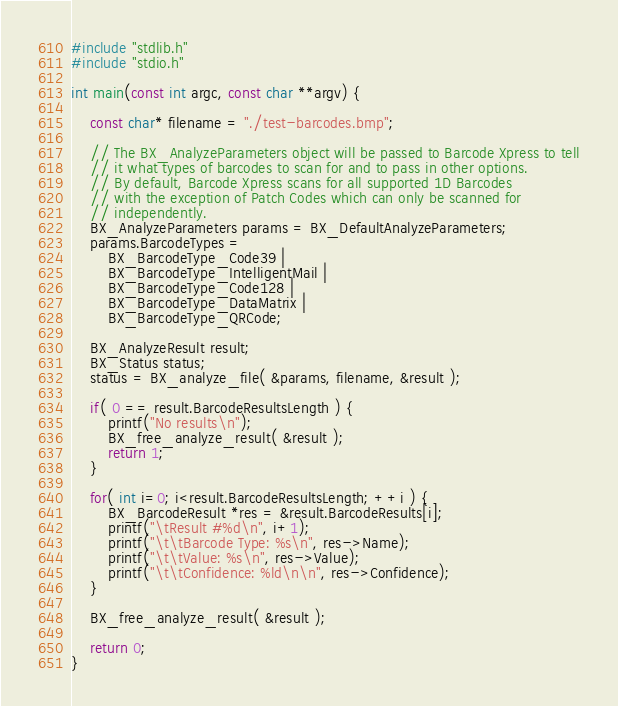<code> <loc_0><loc_0><loc_500><loc_500><_C++_>#include "stdlib.h"
#include "stdio.h"

int main(const int argc, const char **argv) {

    const char* filename = "./test-barcodes.bmp";

    // The BX_AnalyzeParameters object will be passed to Barcode Xpress to tell
    // it what types of barcodes to scan for and to pass in other options.
    // By default, Barcode Xpress scans for all supported 1D Barcodes
    // with the exception of Patch Codes which can only be scanned for 
    // independently.
    BX_AnalyzeParameters params = BX_DefaultAnalyzeParameters;
    params.BarcodeTypes = 
        BX_BarcodeType_Code39 | 
        BX_BarcodeType_IntelligentMail |
        BX_BarcodeType_Code128 |
        BX_BarcodeType_DataMatrix |
        BX_BarcodeType_QRCode;

    BX_AnalyzeResult result;
    BX_Status status;
    status = BX_analyze_file( &params, filename, &result );

    if( 0 == result.BarcodeResultsLength ) {
        printf("No results\n");
        BX_free_analyze_result( &result );
        return 1;
    }

    for( int i=0; i<result.BarcodeResultsLength; ++i ) {
        BX_BarcodeResult *res = &result.BarcodeResults[i];
        printf("\tResult #%d\n", i+1);
        printf("\t\tBarcode Type: %s\n", res->Name);
        printf("\t\tValue: %s\n", res->Value);
        printf("\t\tConfidence: %ld\n\n", res->Confidence);
    }    

    BX_free_analyze_result( &result );

    return 0;
}
</code> 